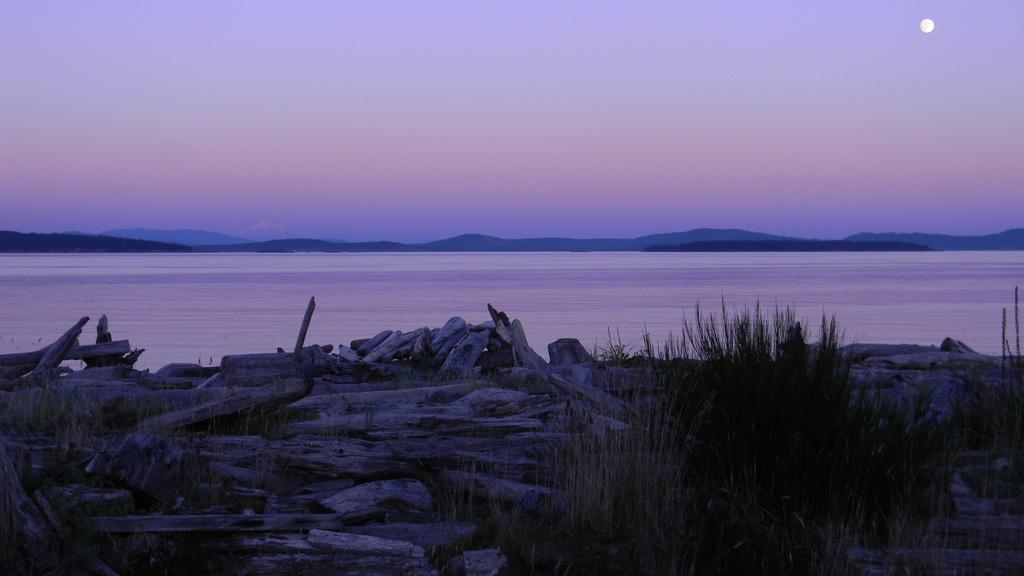What type of natural body of water is present in the image? There is a sea in the image. What type of vegetation can be seen in the image? There are plants in the image. What objects are made of wood in the image? There are wooden sticks in the image. What type of geological formation is visible in the image? There are mountains in the image. What celestial body is visible in the background of the image? The moon is visible in the background of the image. What else can be seen in the background of the image? The sky is visible in the background of the image. What type of tramp can be seen jumping over the channel in the image? There is no tramp or channel present in the image; the image features a sea, plants, wooden sticks, mountains, the moon, and the sky. What type of industrial activity is taking place in the image? There is no industrial activity present in the image; it features a sea, plants, wooden sticks, mountains, the moon, and the sky. 